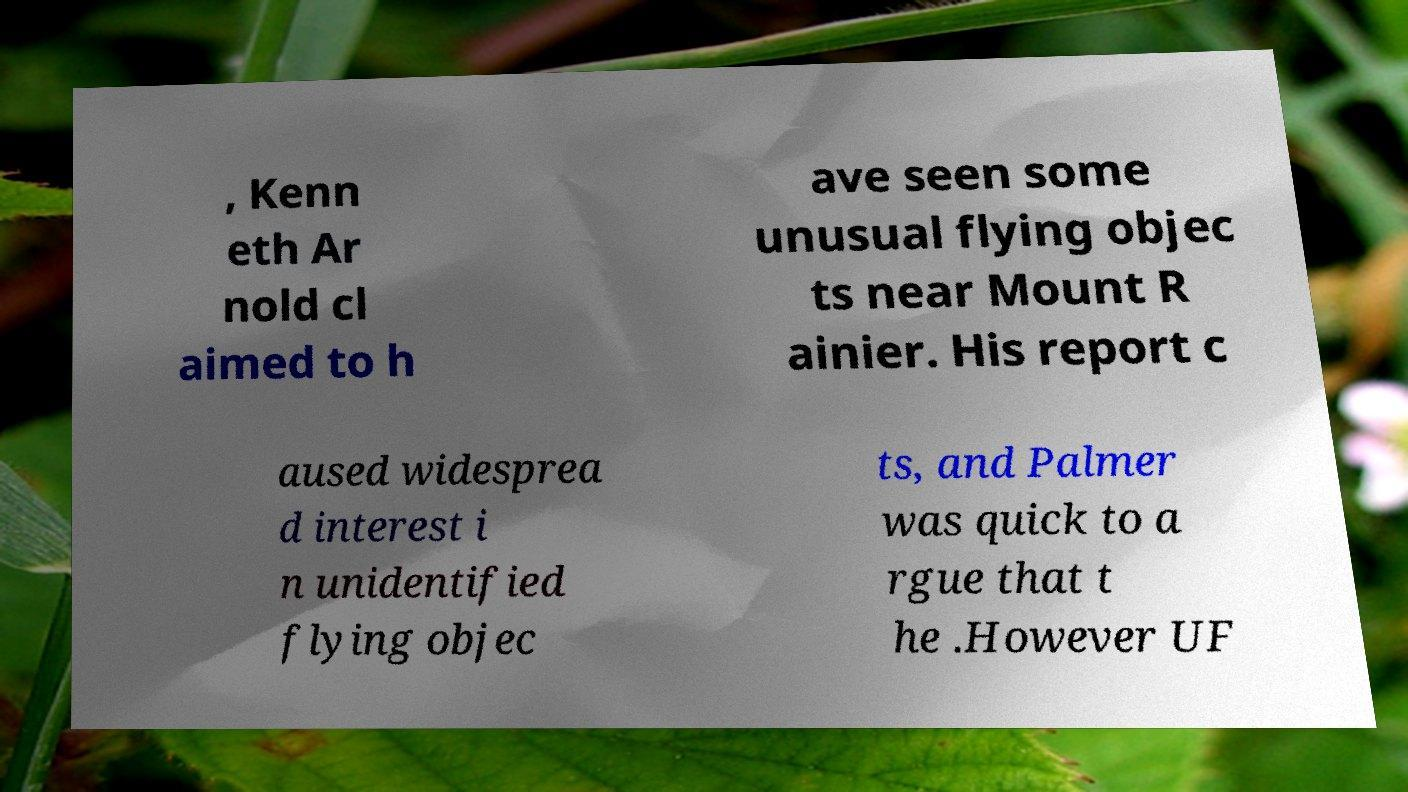Could you extract and type out the text from this image? , Kenn eth Ar nold cl aimed to h ave seen some unusual flying objec ts near Mount R ainier. His report c aused widesprea d interest i n unidentified flying objec ts, and Palmer was quick to a rgue that t he .However UF 